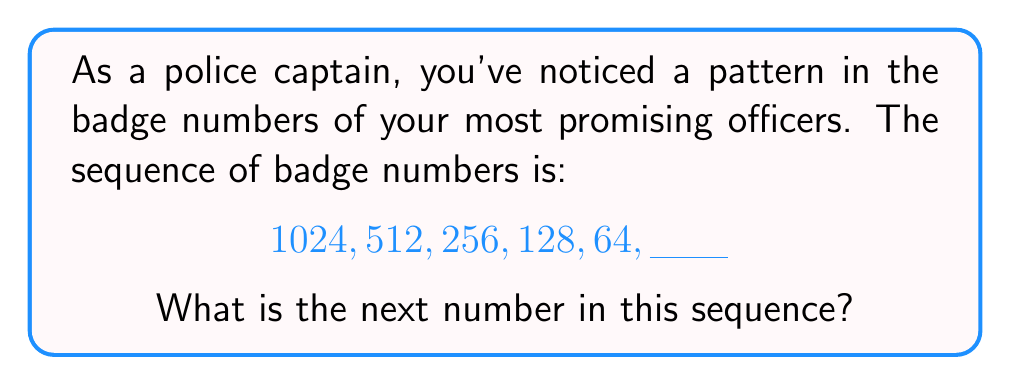Help me with this question. Let's analyze this sequence step-by-step:

1) First, let's look at the relationship between consecutive terms:
   
   1024 → 512
   512 → 256
   256 → 128
   128 → 64

2) We can see that each number is exactly half of the previous number.
   Mathematically, we can express this as:

   $$a_{n+1} = \frac{a_n}{2}$$

   Where $a_n$ represents the nth term in the sequence.

3) We can verify this pattern:
   
   $\frac{1024}{2} = 512$
   $\frac{512}{2} = 256$
   $\frac{256}{2} = 128$
   $\frac{128}{2} = 64$

4) To find the next number, we simply need to divide the last given number by 2:

   $$64 \div 2 = 32$$

Therefore, the next number in the sequence is 32.
Answer: 32 